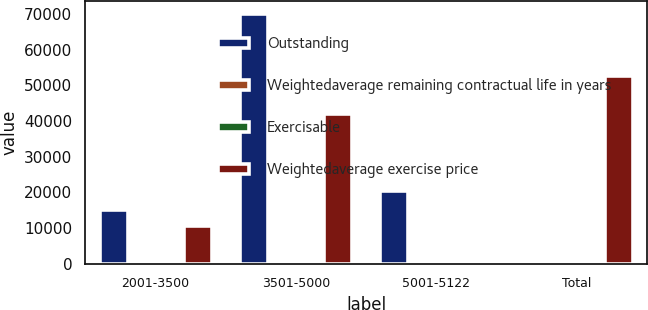Convert chart to OTSL. <chart><loc_0><loc_0><loc_500><loc_500><stacked_bar_chart><ecel><fcel>2001-3500<fcel>3501-5000<fcel>5001-5122<fcel>Total<nl><fcel>Outstanding<fcel>15200<fcel>70088<fcel>20294<fcel>51.22<nl><fcel>Weightedaverage remaining contractual life in years<fcel>25.01<fcel>41.18<fcel>51.22<fcel>40.78<nl><fcel>Exercisable<fcel>4.3<fcel>4.5<fcel>5.1<fcel>4.6<nl><fcel>Weightedaverage exercise price<fcel>10490<fcel>41990<fcel>112<fcel>52592<nl></chart> 